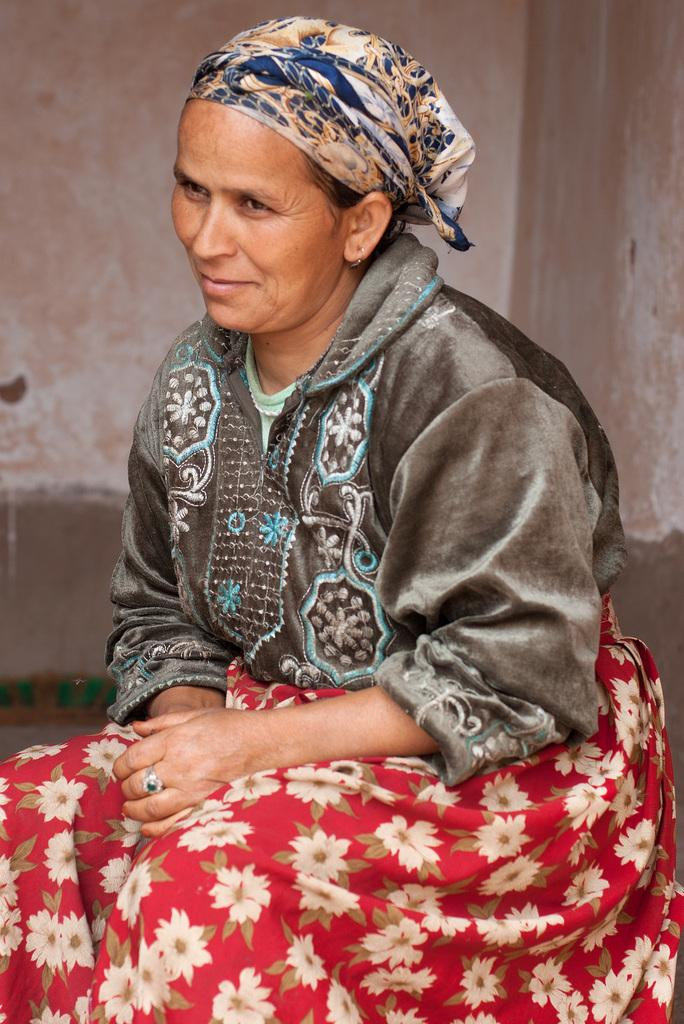What is the main subject of the image? There is a lady sitting in the center of the image. What can be seen in the background of the image? There is a wall in the background of the image. What type of music is the lady playing in the image? There is no indication in the image that the lady is playing any music, so it cannot be determined from the picture. 